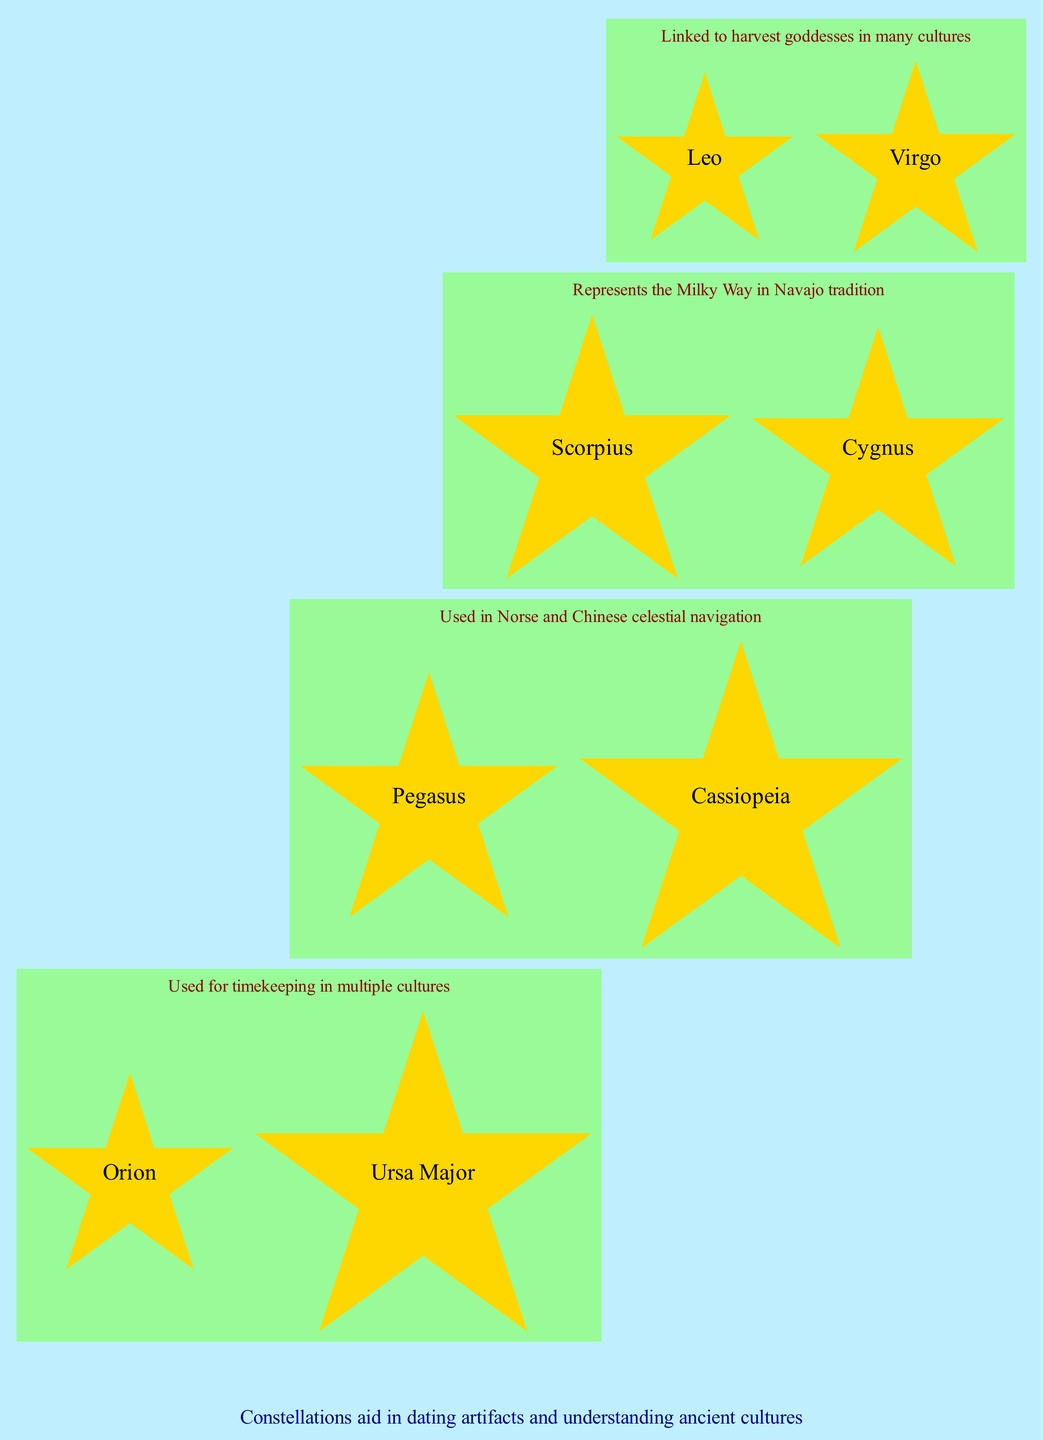What constellations are visible in Spring? According to the diagram, in Spring the visible constellations are Leo and Virgo.
Answer: Leo, Virgo What is the cultural significance of Orion? The diagram indicates that Orion is central to many ancient hunting myths.
Answer: Central to many ancient hunting myths How many seasons are represented in the diagram? By examining the diagram, we can count a total of four seasons: Spring, Summer, Autumn, and Winter.
Answer: 4 Which constellation is linked to Greek mythology? Referring to the diagram, Pegasus is identified as the constellation linked to Greek mythology.
Answer: Pegasus What seasonal constellation is associated with harvest goddesses? The diagram shows Virgo as the constellation associated with harvest goddesses in many cultures during Spring.
Answer: Virgo What does Ursa Major represent in ancient cultures? Based on the information in the diagram, Ursa Major is used for timekeeping in multiple cultures.
Answer: Used for timekeeping in multiple cultures Which constellation appears in both Summer and its significance in Native American tradition? The diagram reveals that Cygnus in Summer represents the Milky Way in Navajo tradition.
Answer: Cygnus How are the constellations connected to archaeological studies according to the note? The note in the diagram suggests that constellations aid in dating artifacts and understanding ancient cultures.
Answer: Dating artifacts and understanding ancient cultures Which season has the constellation associated with Egyptian astronomy? The diagram indicates that Scorpius, which is associated with Egyptian astronomy, is visible in Summer.
Answer: Summer What is the significance of Cassiopeia in Autumn? The diagram states that Cassiopeia is used in Norse and Chinese celestial navigation during Autumn.
Answer: Used in Norse and Chinese celestial navigation 